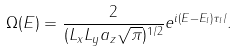<formula> <loc_0><loc_0><loc_500><loc_500>\Omega ( E ) = \frac { 2 } { ( L _ { x } L _ { y } a _ { z } \sqrt { \pi } ) ^ { 1 / 2 } } e ^ { i ( E - E _ { l } ) \tau _ { l } / } .</formula> 